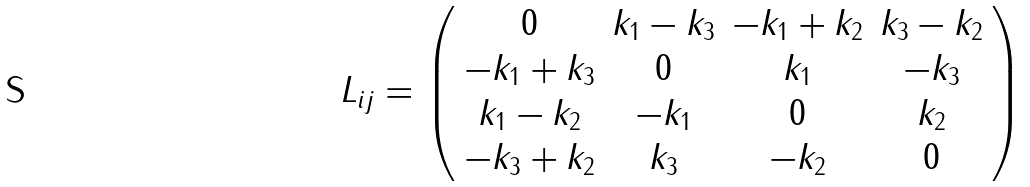Convert formula to latex. <formula><loc_0><loc_0><loc_500><loc_500>L _ { i j } = \left ( \begin{array} { c c c c } 0 & k _ { 1 } - k _ { 3 } & - k _ { 1 } + k _ { 2 } & k _ { 3 } - k _ { 2 } \\ - k _ { 1 } + k _ { 3 } & 0 & k _ { 1 } & - k _ { 3 } \\ k _ { 1 } - k _ { 2 } & - k _ { 1 } & 0 & k _ { 2 } \\ - k _ { 3 } + k _ { 2 } & k _ { 3 } & - k _ { 2 } & 0 \end{array} \right )</formula> 